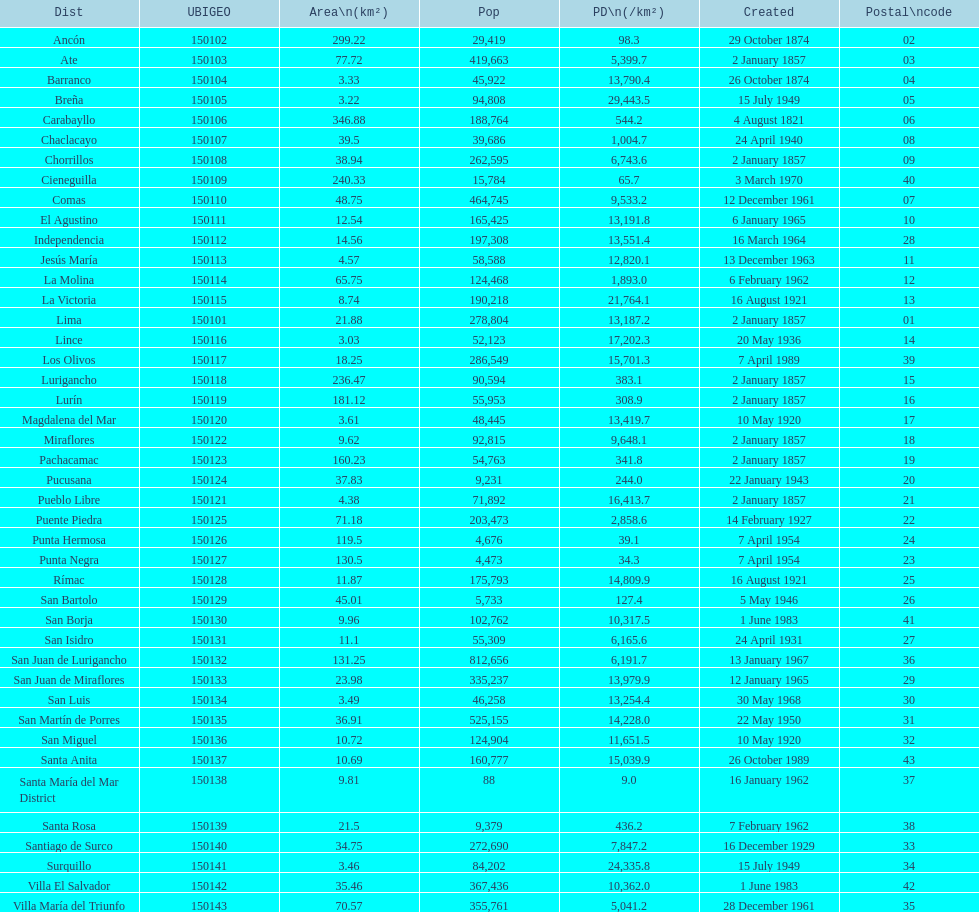How many districts are there in this city? 43. 